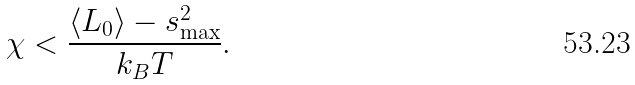Convert formula to latex. <formula><loc_0><loc_0><loc_500><loc_500>\chi < \frac { \left \langle L _ { 0 } \right \rangle - s _ { \max } ^ { 2 } } { k _ { B } T } .</formula> 